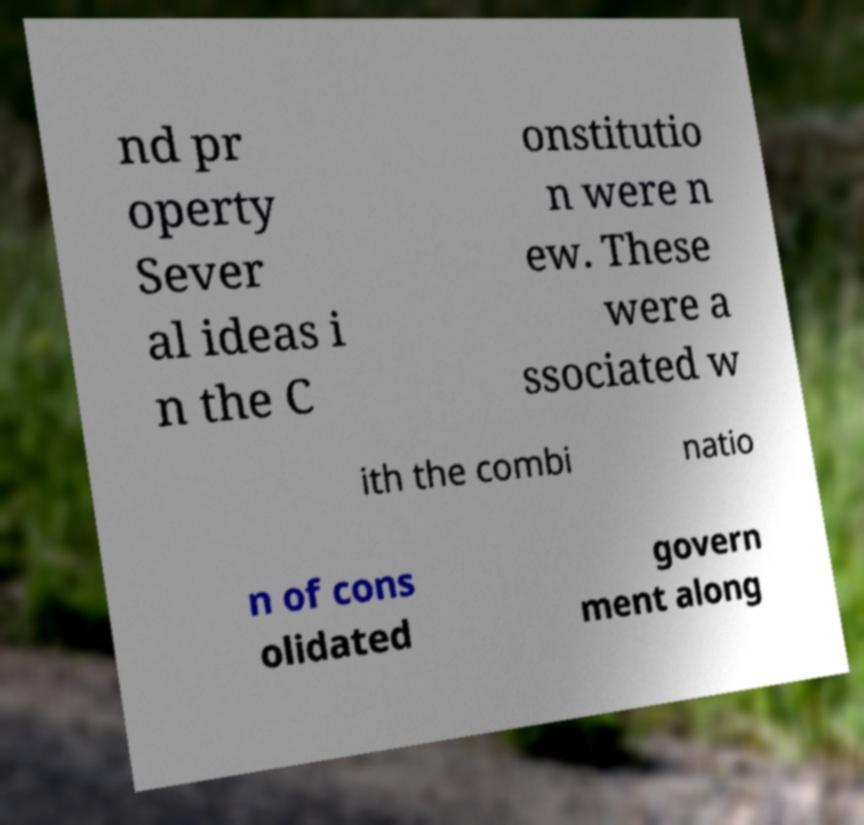Can you read and provide the text displayed in the image?This photo seems to have some interesting text. Can you extract and type it out for me? nd pr operty Sever al ideas i n the C onstitutio n were n ew. These were a ssociated w ith the combi natio n of cons olidated govern ment along 